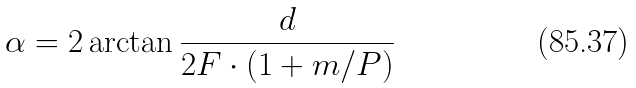<formula> <loc_0><loc_0><loc_500><loc_500>\alpha = 2 \arctan { \frac { d } { 2 F \cdot ( 1 + m / P ) } }</formula> 